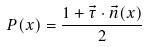<formula> <loc_0><loc_0><loc_500><loc_500>P ( x ) = \frac { 1 + \vec { \tau } \cdot \vec { n } ( x ) } { 2 }</formula> 